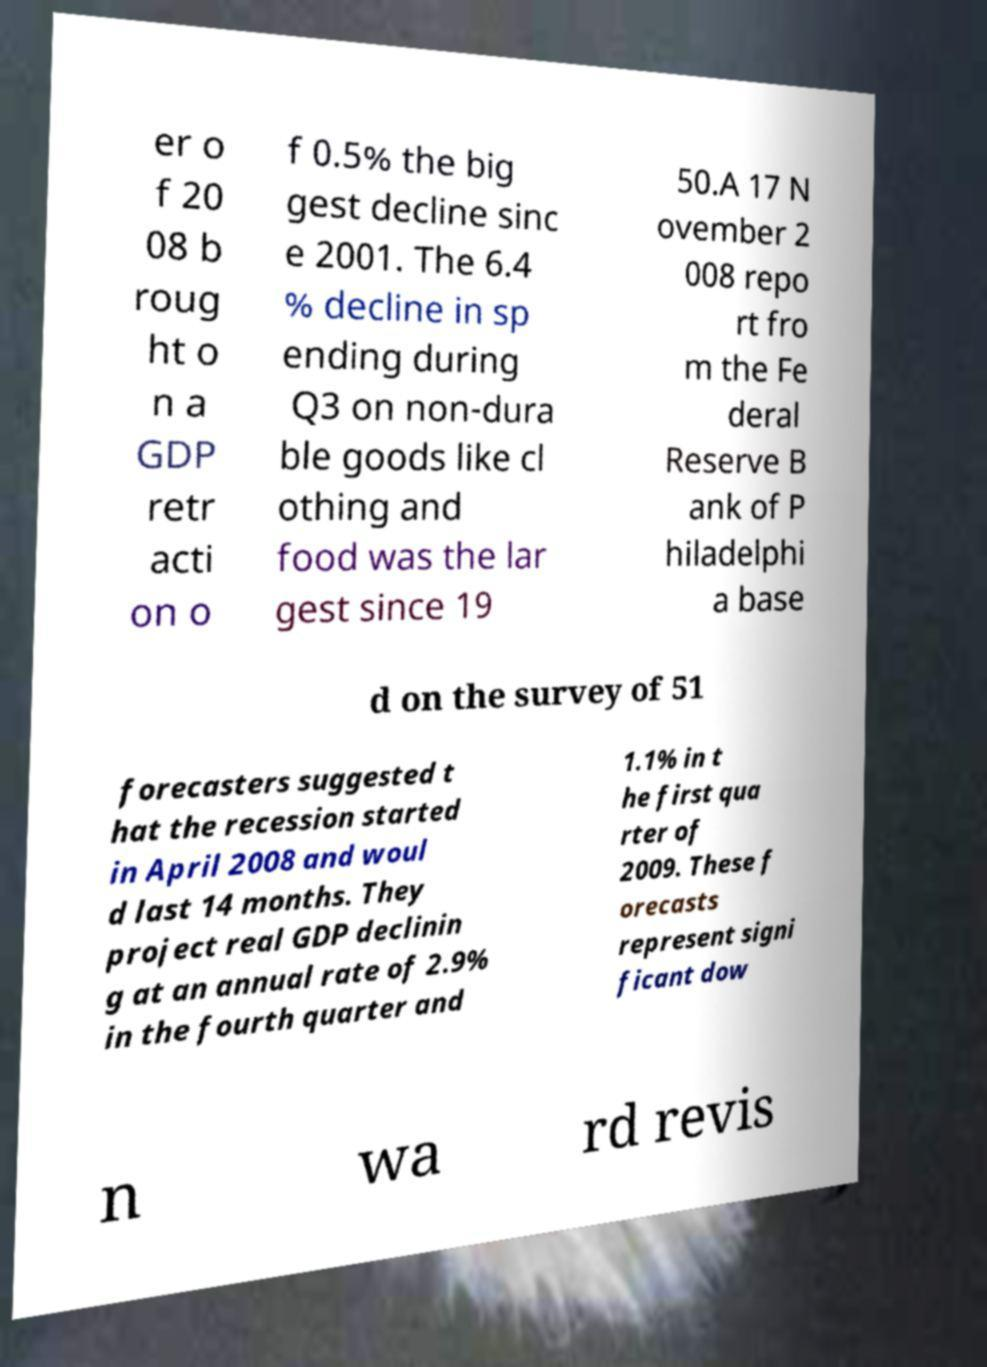Please read and relay the text visible in this image. What does it say? er o f 20 08 b roug ht o n a GDP retr acti on o f 0.5% the big gest decline sinc e 2001. The 6.4 % decline in sp ending during Q3 on non-dura ble goods like cl othing and food was the lar gest since 19 50.A 17 N ovember 2 008 repo rt fro m the Fe deral Reserve B ank of P hiladelphi a base d on the survey of 51 forecasters suggested t hat the recession started in April 2008 and woul d last 14 months. They project real GDP declinin g at an annual rate of 2.9% in the fourth quarter and 1.1% in t he first qua rter of 2009. These f orecasts represent signi ficant dow n wa rd revis 